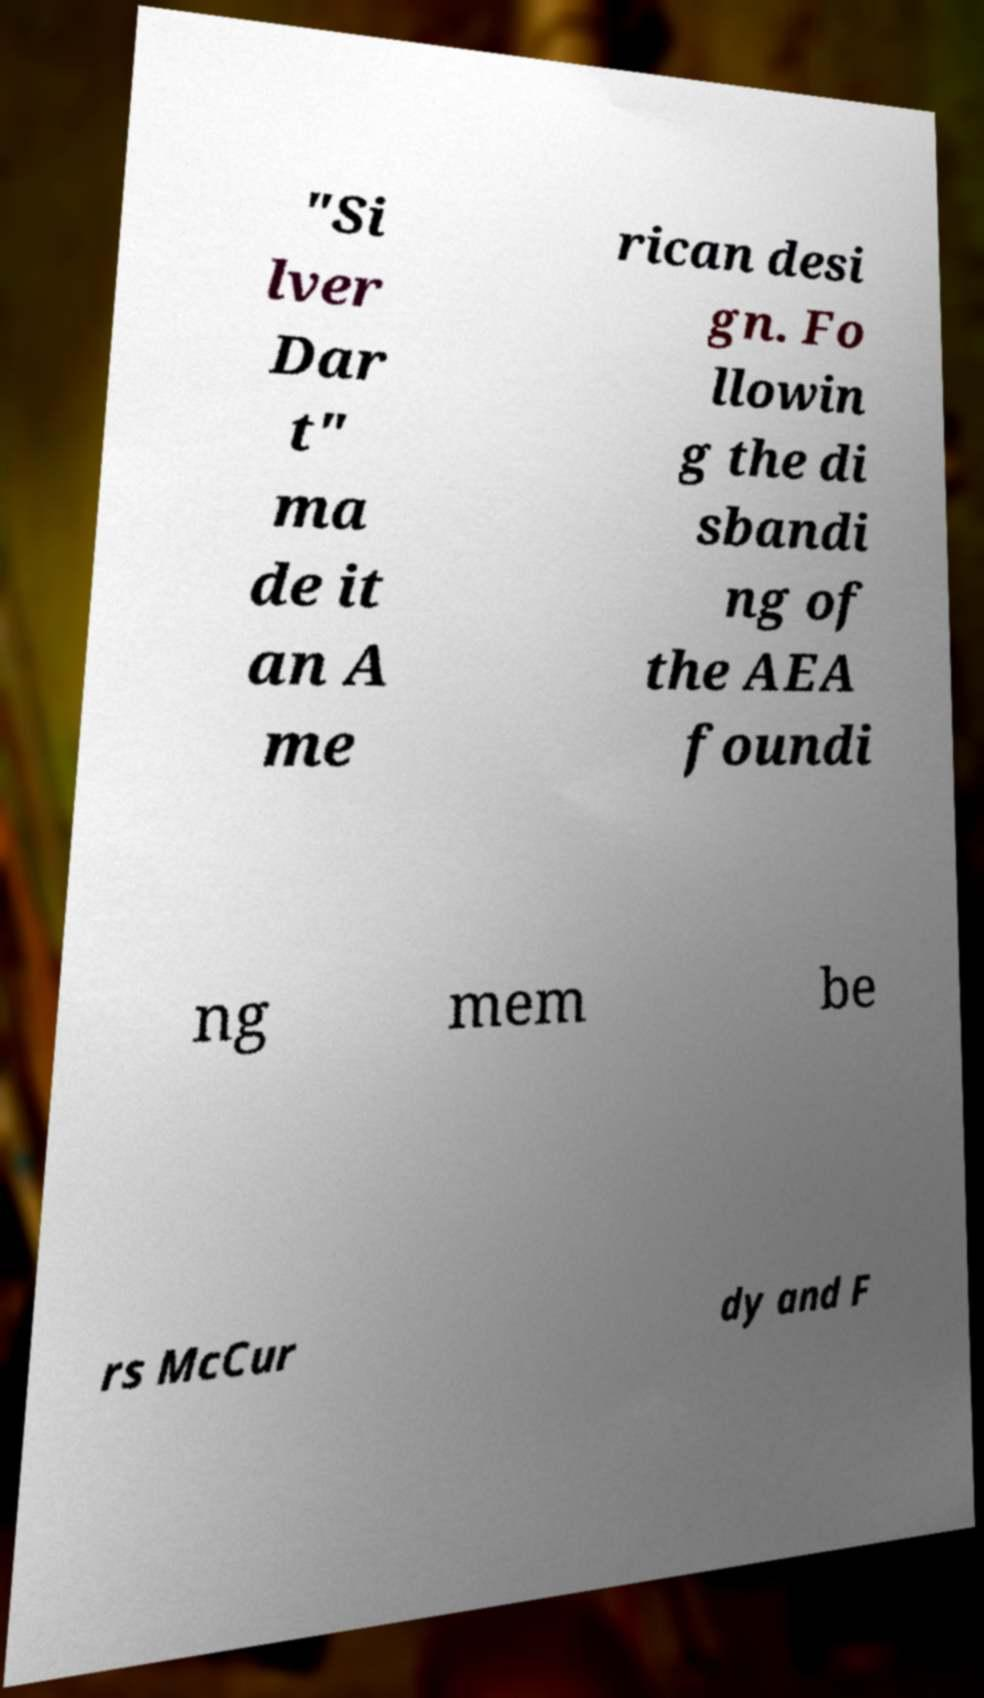Could you extract and type out the text from this image? "Si lver Dar t" ma de it an A me rican desi gn. Fo llowin g the di sbandi ng of the AEA foundi ng mem be rs McCur dy and F 